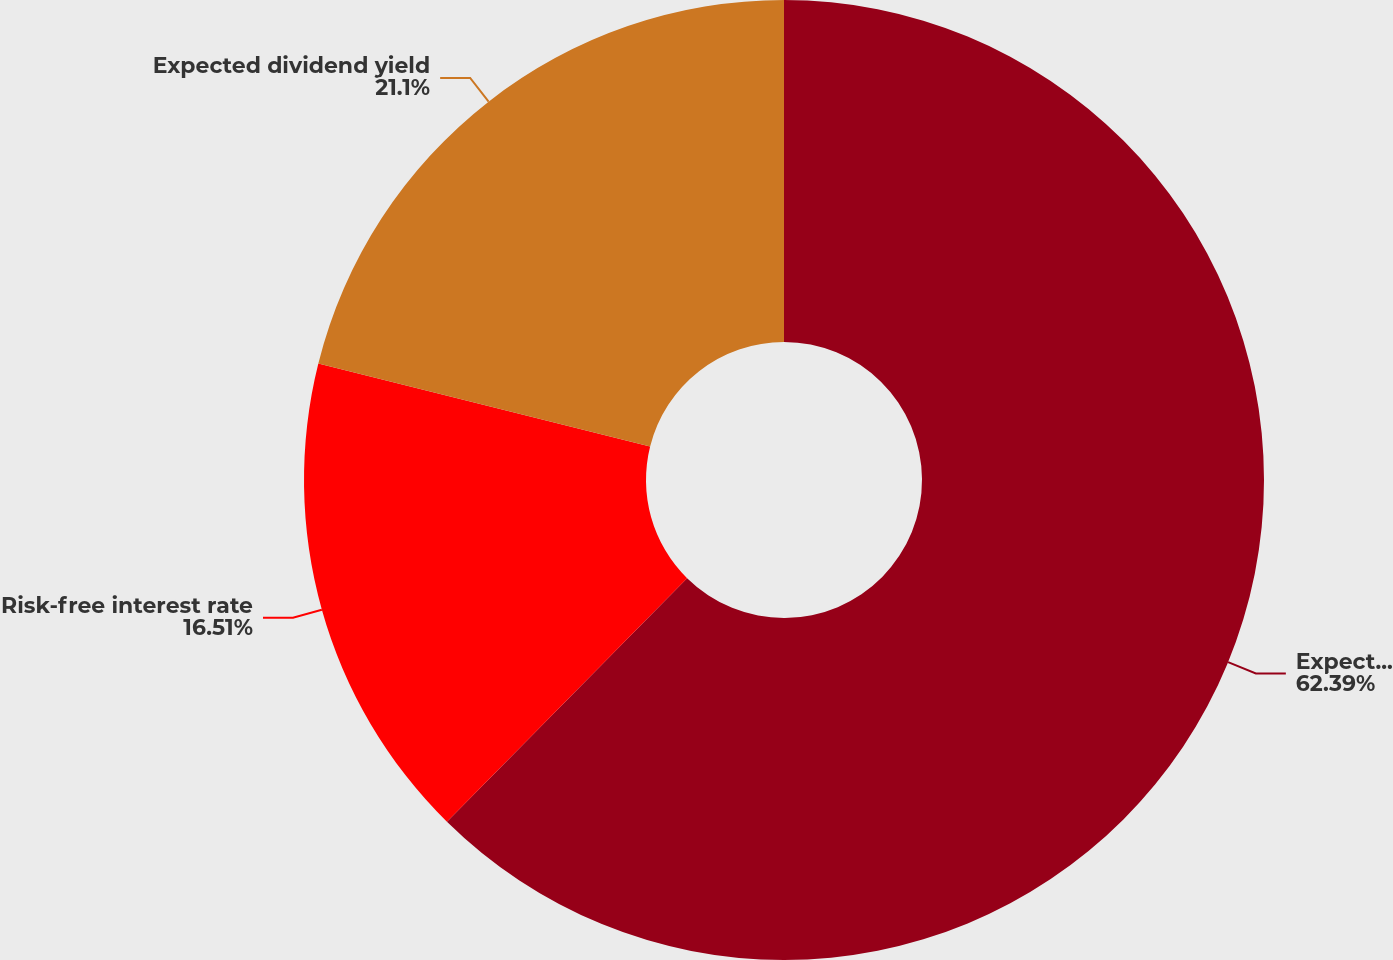<chart> <loc_0><loc_0><loc_500><loc_500><pie_chart><fcel>Expected volatility<fcel>Risk-free interest rate<fcel>Expected dividend yield<nl><fcel>62.39%<fcel>16.51%<fcel>21.1%<nl></chart> 